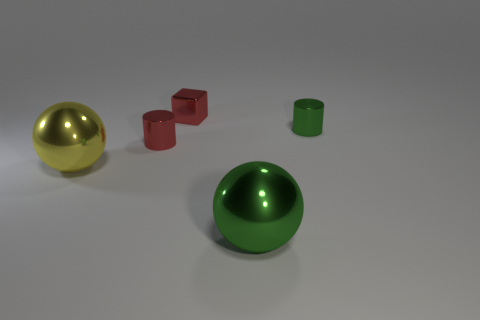Add 1 big green balls. How many objects exist? 6 Subtract all cubes. How many objects are left? 4 Subtract 0 yellow cylinders. How many objects are left? 5 Subtract all red blocks. Subtract all large green things. How many objects are left? 3 Add 1 yellow metal things. How many yellow metal things are left? 2 Add 5 big things. How many big things exist? 7 